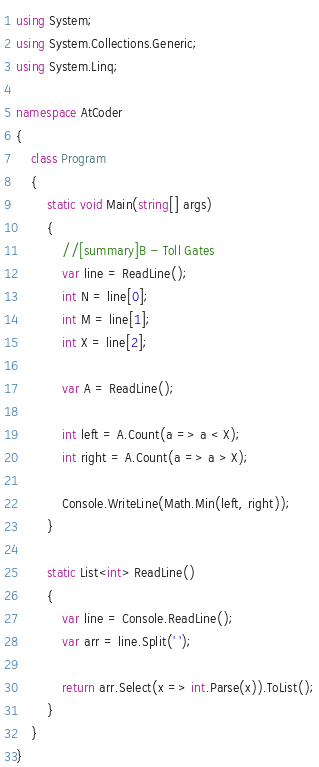Convert code to text. <code><loc_0><loc_0><loc_500><loc_500><_C#_>using System;
using System.Collections.Generic;
using System.Linq;

namespace AtCoder
{
    class Program
    {
        static void Main(string[] args)
        {
            //[summary]B - Toll Gates
            var line = ReadLine();
            int N = line[0];
            int M = line[1];
            int X = line[2];

            var A = ReadLine();

            int left = A.Count(a => a < X);
            int right = A.Count(a => a > X);

            Console.WriteLine(Math.Min(left, right));
        }

        static List<int> ReadLine()
        {
            var line = Console.ReadLine();
            var arr = line.Split(' ');

            return arr.Select(x => int.Parse(x)).ToList();
        }
    }
}</code> 